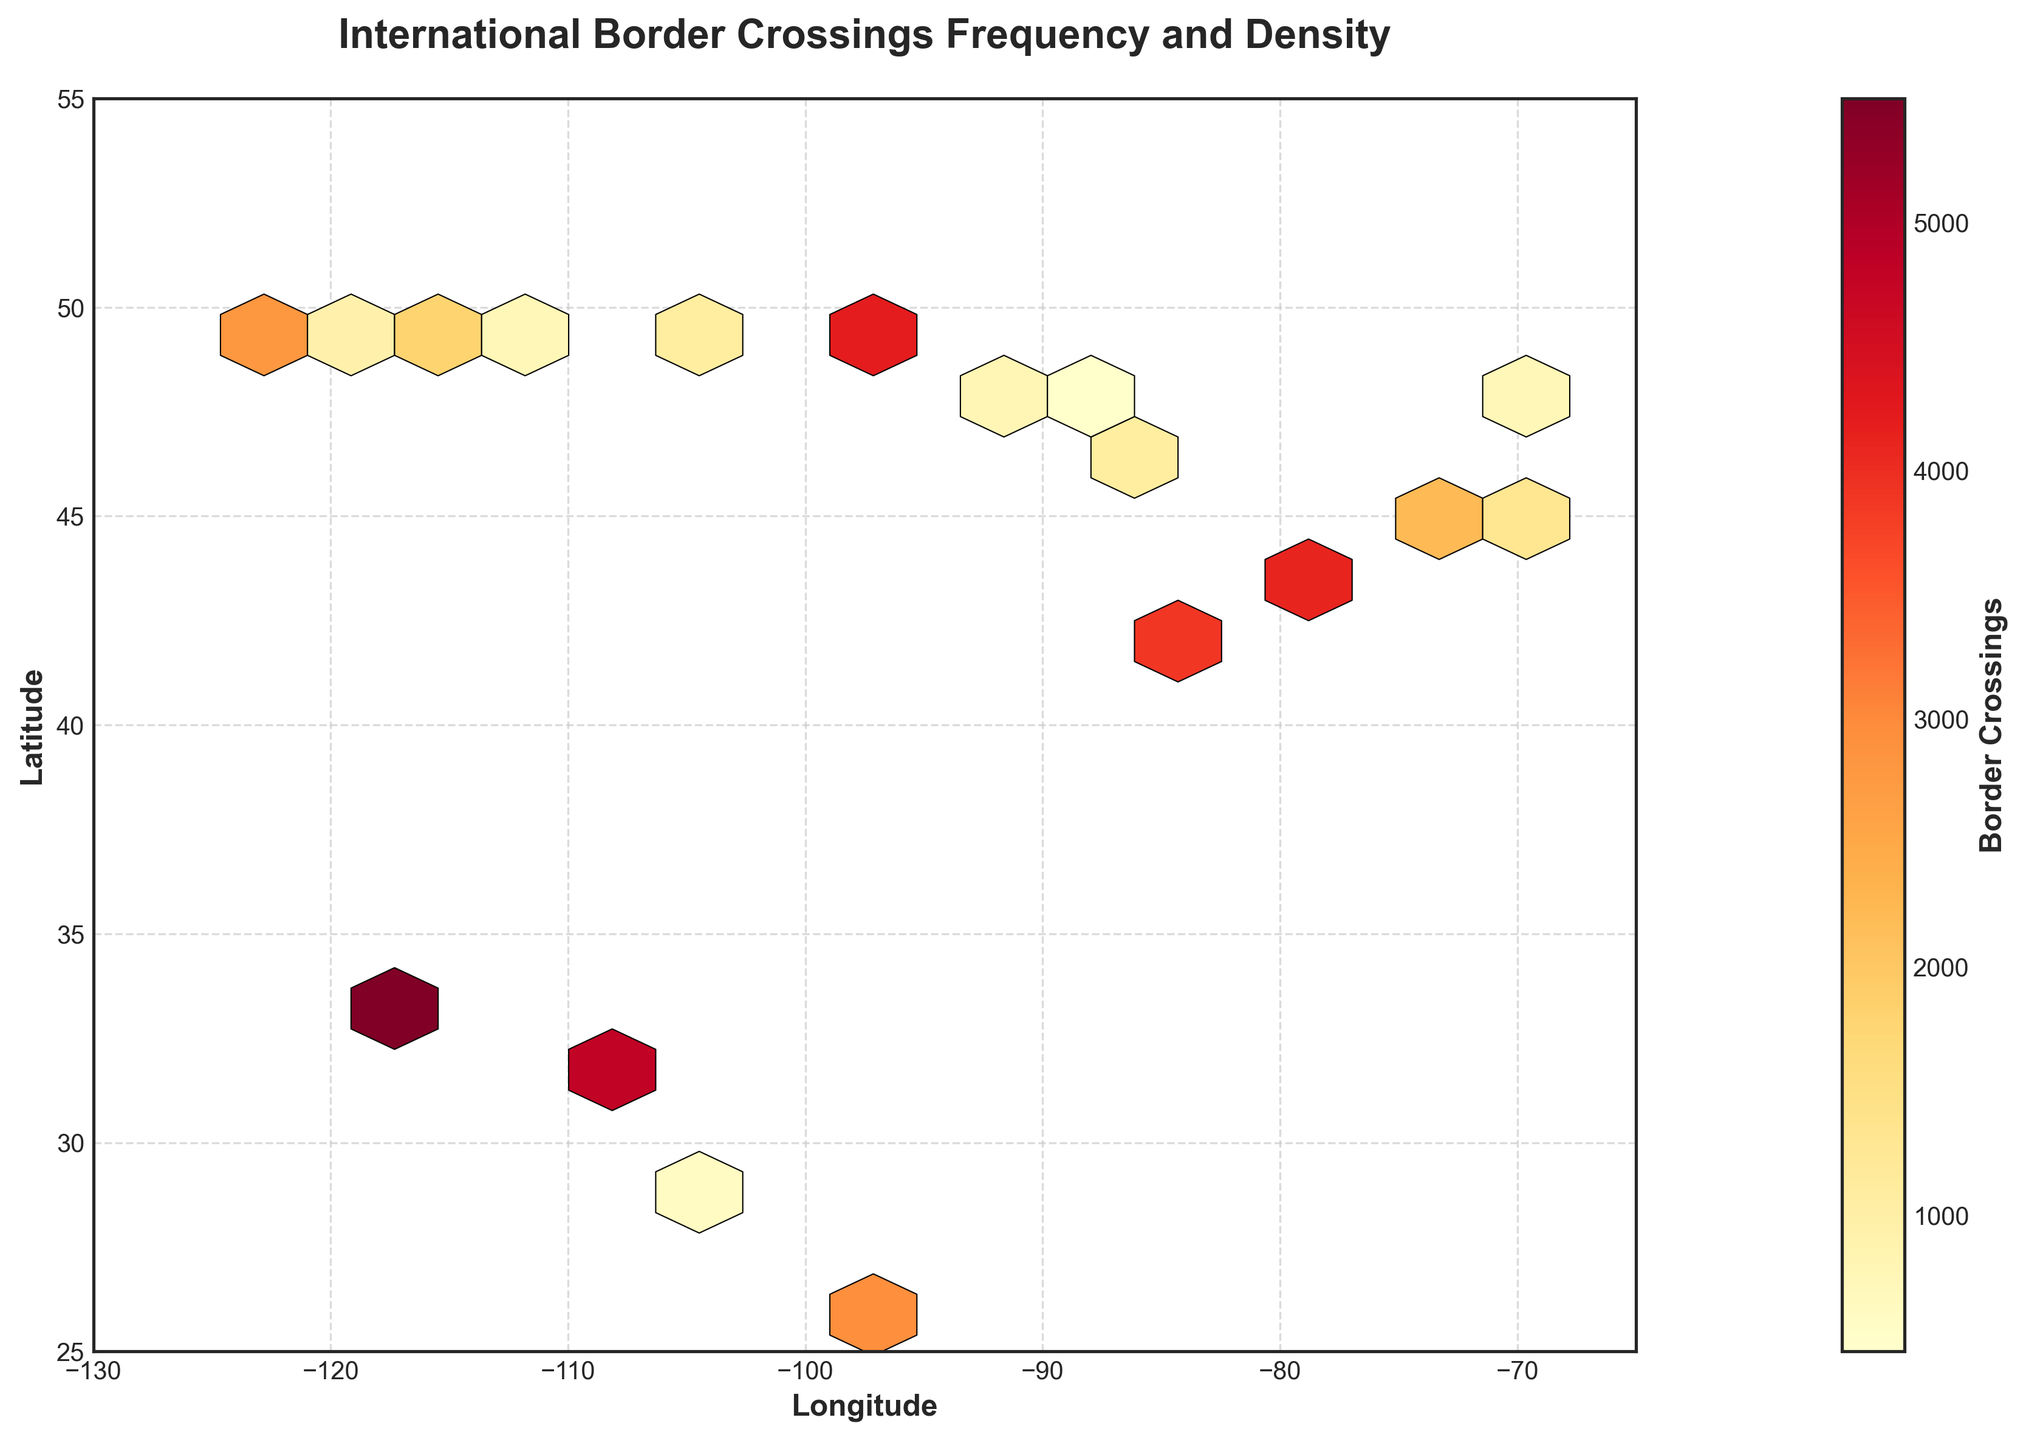What is the title of the figure? The title is usually displayed at the top of the plot. The text in the title describes what the figure represents. In this case, the title reads "International Border Crossings Frequency and Density".
Answer: International Border Crossings Frequency and Density What do the x and y axes represent? The labels on the x-axis and y-axis indicate what each axis measures. Here, the x-axis label is "Longitude" and the y-axis label is "Latitude".
Answer: Longitude and Latitude How is the frequency of border crossings displayed on the plot? In a hexbin plot, the frequency of border crossings is represented through the color of the hexagons. The color varies based on the density of points within each hexagon.
Answer: By color density of hexagons Which region shows the highest density of border crossings? To determine the region with the highest density, look for the hexagon with the darkest color (on the 'YlOrRd' scale) which indicates the highest frequency. This appears to be around the latitudes 32 to 35 and longitudes -118 to -114.
Answer: Southern California near latitude 32.5, longitude -117.0 What is the color indicating the lowest density of border crossings? The color scale ranges from a light shade of yellow (indicating the lowest density) to a dark red (indicating the highest density). The lightest shade of yellow represents the lowest density of border crossings.
Answer: Light Yellow Between which longitudes and latitudes is the plot area confined? The given plot area can be inferred by checking the limits on the x and y axes. The x-axis ranges from -130 to -65 (Longitude) and the y-axis ranges from 25 to 55 (Latitude).
Answer: -130 to -65 longitude and 25 to 55 latitude What can you discern about the regions around latitude 49 and longitudes ranging from 116 to 123? By examining the plot, different shades of colors indicate varying frequencies. Around latitude 49 and longitudes 116 to 123, there are multiple hexagons with medium to high densities, implying frequent border crossings in these areas.
Answer: Medium to high density Is the density of border crossings uniform across the US-Mexico and US-Canada borders? By comparing the colors and densities of the hexagons along these borders, it can be observed that densities vary greatly with certain regions (e.g., near California for Mexico and near New York for Canada) showing higher densities.
Answer: No What does the colorbar represent in the plot? The colorbar on the side of the plot shows a gradient of colors that correspond to the number of border crossings, providing a reference to interpret the densities in the hexagons.
Answer: Border Crossings Where are the lowest border crossings happening along the US-Canada border? The lowest border crossings can be identified by the lighter-colored hexagons. These appear around latitudes between 45 and 48 and longitudes -90 to -120.
Answer: Between latitudes 45-48 and longitudes -90 to -120 